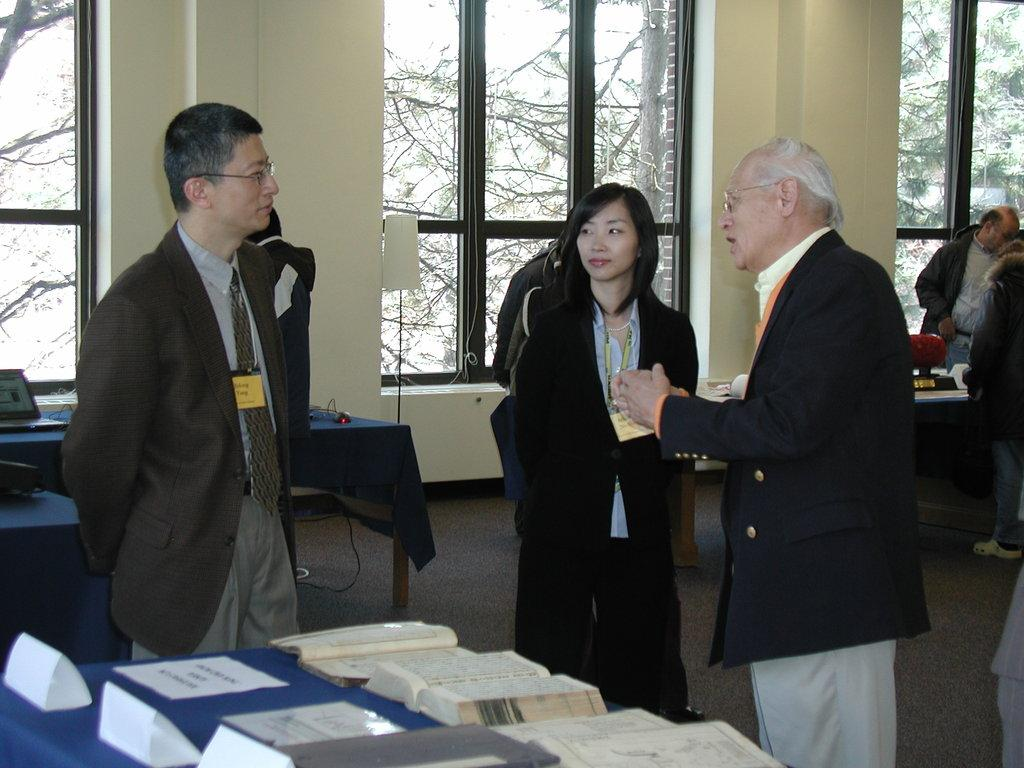How many people are in the image? There are three persons in the image. Can you describe the gender of the persons? Two of the persons are men, and one is a woman. What are the persons doing in the image? The three persons are standing near a table. What can be seen through the window in the image? Trees are visible through the window. What subject is the woman teaching in the image? There is no indication in the image that the woman is teaching a subject, as the focus is on the persons standing near a table. 